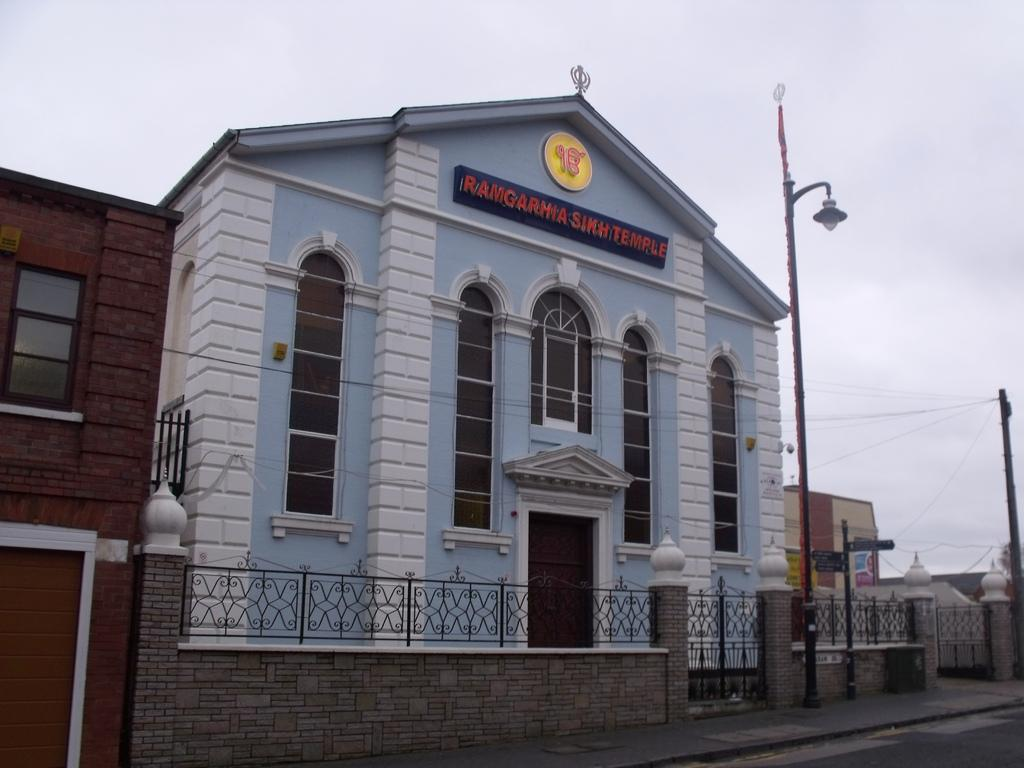What type of structure is in the picture? There is a house in the picture. What colors are used on the house? The house has white and blue colors. What type of windows does the house have? The house has glass windows. What is located at the front bottom side of the house? There is a gate, grill railing, and a lamp post in the front bottom side of the house. What is visible at the top of the image? The sky is visible at the top of the image. What type of verse can be seen written on the house in the image? There is no verse visible on the house in the image. What emotion is being expressed by the house in the image? The house is an inanimate object and cannot express emotions like hate. 